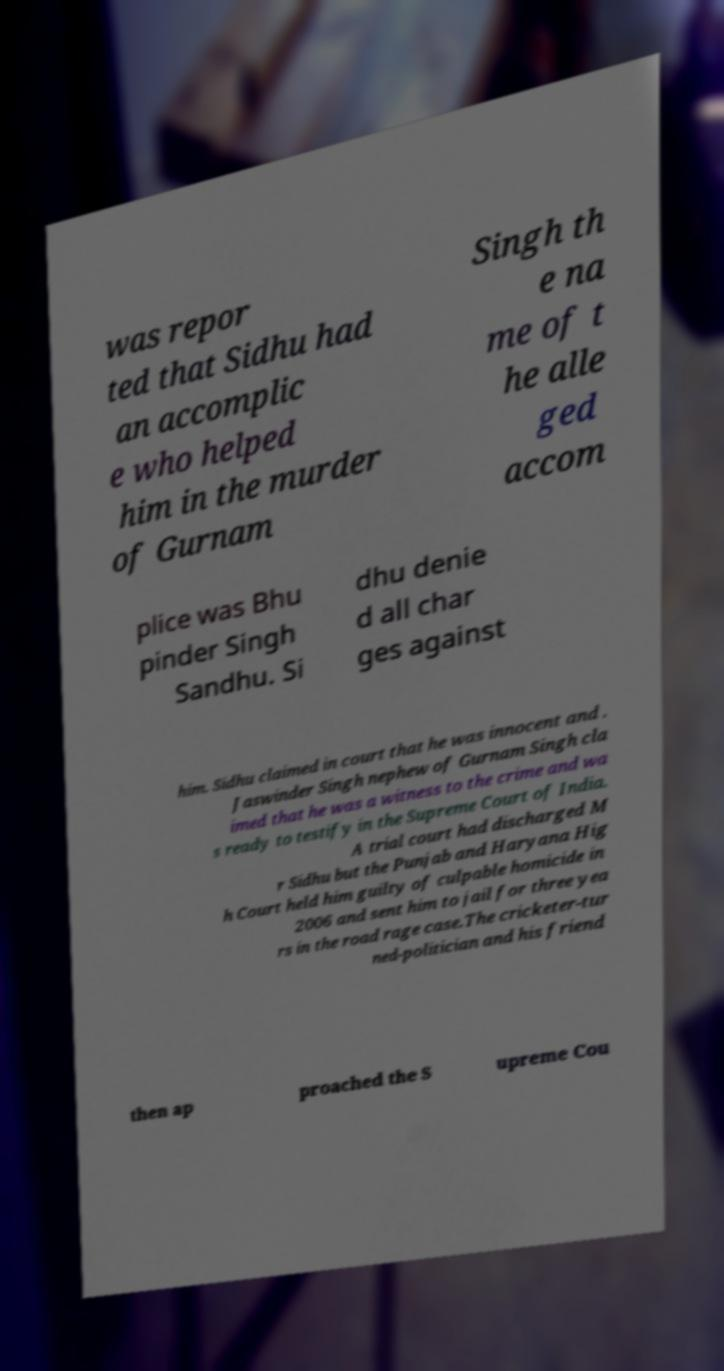Can you accurately transcribe the text from the provided image for me? was repor ted that Sidhu had an accomplic e who helped him in the murder of Gurnam Singh th e na me of t he alle ged accom plice was Bhu pinder Singh Sandhu. Si dhu denie d all char ges against him. Sidhu claimed in court that he was innocent and . Jaswinder Singh nephew of Gurnam Singh cla imed that he was a witness to the crime and wa s ready to testify in the Supreme Court of India. A trial court had discharged M r Sidhu but the Punjab and Haryana Hig h Court held him guilty of culpable homicide in 2006 and sent him to jail for three yea rs in the road rage case.The cricketer-tur ned-politician and his friend then ap proached the S upreme Cou 